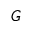<formula> <loc_0><loc_0><loc_500><loc_500>G</formula> 